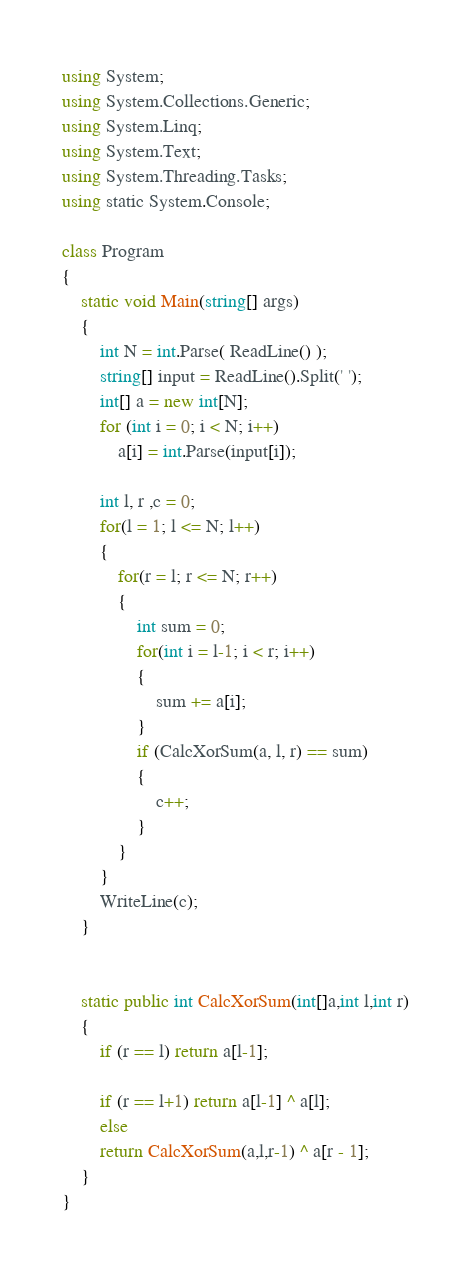<code> <loc_0><loc_0><loc_500><loc_500><_C#_>using System;
using System.Collections.Generic;
using System.Linq;
using System.Text;
using System.Threading.Tasks;
using static System.Console;

class Program
{
    static void Main(string[] args)
    {
        int N = int.Parse( ReadLine() );
        string[] input = ReadLine().Split(' ');
        int[] a = new int[N];
        for (int i = 0; i < N; i++)
            a[i] = int.Parse(input[i]);

        int l, r ,c = 0;
        for(l = 1; l <= N; l++)
        {
            for(r = l; r <= N; r++)
            {
                int sum = 0;
                for(int i = l-1; i < r; i++)
                {
                    sum += a[i];
                }
                if (CalcXorSum(a, l, r) == sum)
                {
                    c++;
                }
            }
        }
        WriteLine(c);
    }

   
    static public int CalcXorSum(int[]a,int l,int r)
    {
        if (r == l) return a[l-1];

        if (r == l+1) return a[l-1] ^ a[l];
        else
        return CalcXorSum(a,l,r-1) ^ a[r - 1]; 
    }
} </code> 